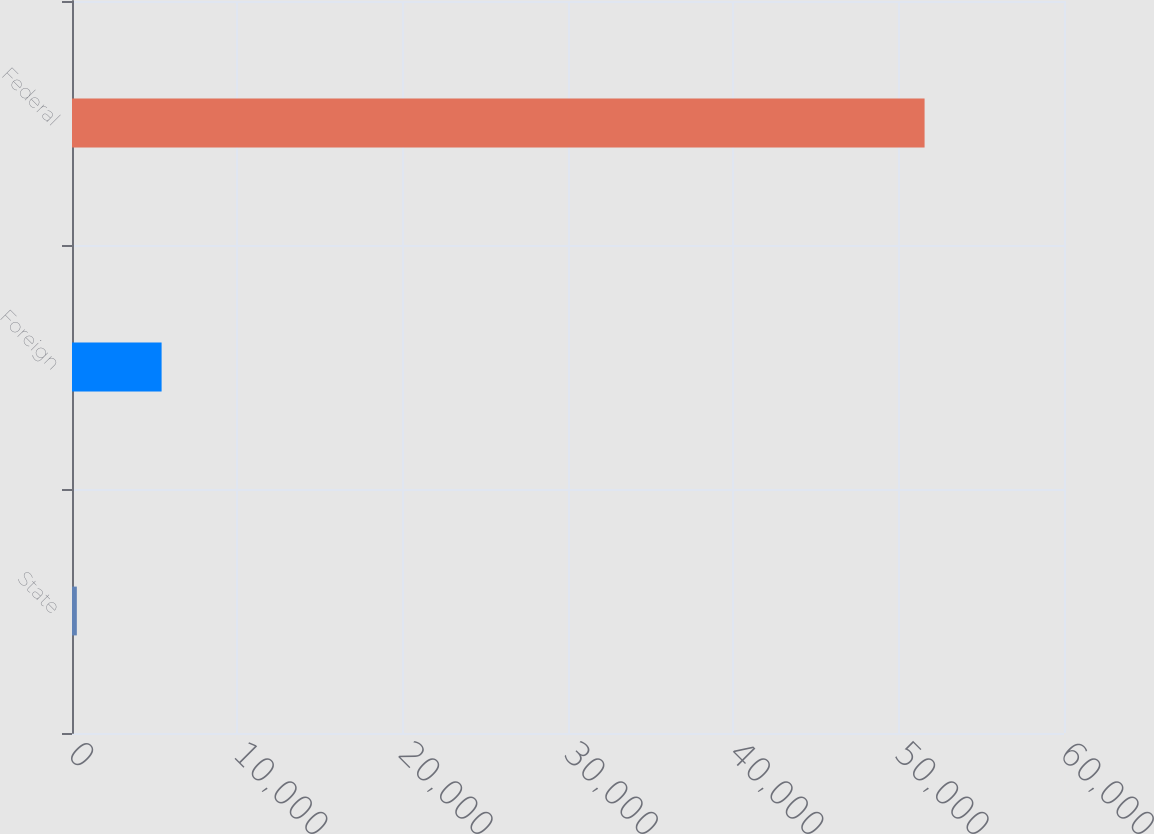Convert chart to OTSL. <chart><loc_0><loc_0><loc_500><loc_500><bar_chart><fcel>State<fcel>Foreign<fcel>Federal<nl><fcel>292<fcel>5419.5<fcel>51567<nl></chart> 